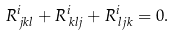Convert formula to latex. <formula><loc_0><loc_0><loc_500><loc_500>R ^ { i } _ { \, j k l } + R ^ { i } _ { \, k l j } + R ^ { i } _ { \, l j k } = 0 .</formula> 